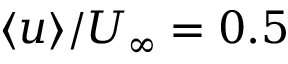<formula> <loc_0><loc_0><loc_500><loc_500>\langle u \rangle / U _ { \infty } = 0 . 5</formula> 